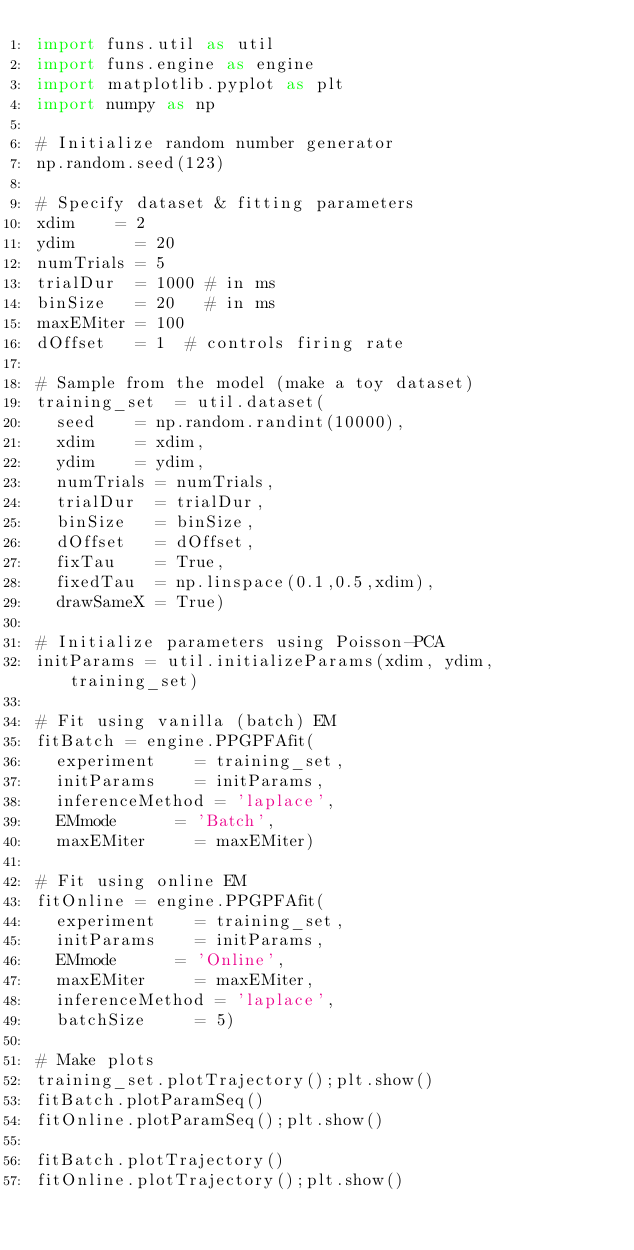Convert code to text. <code><loc_0><loc_0><loc_500><loc_500><_Python_>import funs.util as util
import funs.engine as engine
import matplotlib.pyplot as plt
import numpy as np

# Initialize random number generator
np.random.seed(123)

# Specify dataset & fitting parameters
xdim 	  = 2		
ydim      = 20		
numTrials = 5		
trialDur  = 1000 # in ms
binSize   = 20	 # in ms
maxEMiter = 100		
dOffset   = 1	 # controls firing rate

# Sample from the model (make a toy dataset)
training_set  = util.dataset(
	seed	  = np.random.randint(10000),
	xdim 	  = xdim,
	ydim 	  = ydim,
	numTrials = numTrials,
	trialDur  = trialDur,
	binSize   = binSize,
	dOffset   = dOffset,
	fixTau 	  = True, 
	fixedTau  = np.linspace(0.1,0.5,xdim),
	drawSameX = True)

# Initialize parameters using Poisson-PCA
initParams = util.initializeParams(xdim, ydim, training_set)

# Fit using vanilla (batch) EM
fitBatch = engine.PPGPFAfit(
	experiment 		= training_set,
	initParams 		= initParams,
	inferenceMethod = 'laplace',
	EMmode 			= 'Batch',
	maxEMiter 		= maxEMiter)

# Fit using online EM
fitOnline = engine.PPGPFAfit(
 	experiment 		= training_set,
 	initParams 		= initParams,
 	EMmode 			= 'Online',
 	maxEMiter 		= maxEMiter,
 	inferenceMethod = 'laplace',
	batchSize 		= 5)

# Make plots
training_set.plotTrajectory();plt.show()
fitBatch.plotParamSeq()
fitOnline.plotParamSeq();plt.show()

fitBatch.plotTrajectory()
fitOnline.plotTrajectory();plt.show()
</code> 